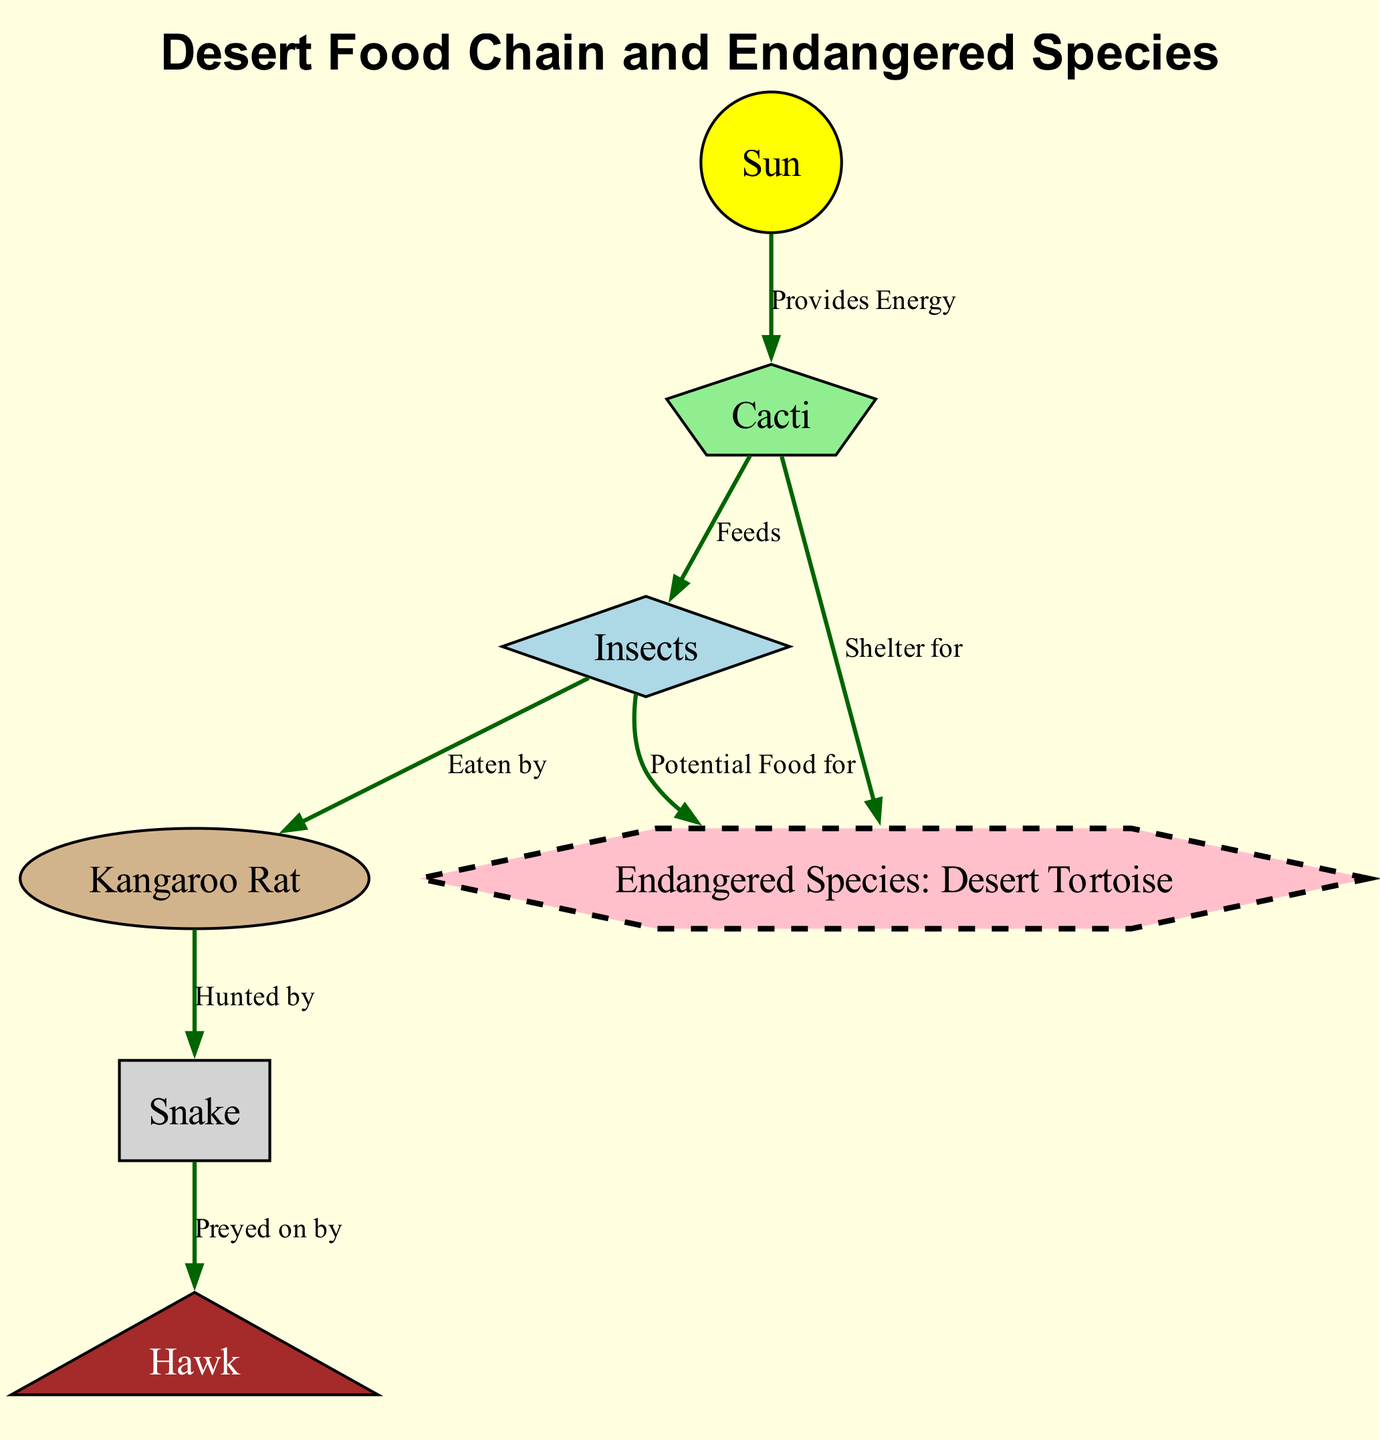What is the title of the diagram? The title is explicitly stated at the top of the diagram, which is designed to provide context for the visual representation of the information contained within.
Answer: Desert Food Chain and Endangered Species How many nodes are present in the diagram? To find the number of nodes, we simply count all unique entities represented in the diagram. The nodes include the Sun, Cacti, Insects, Kangaroo Rat, Snake, Hawk, and Endangered Species. There are a total of seven nodes.
Answer: 7 What relationship does the cacti have with the insects? By examining the edge connecting the two nodes, we see that Cacti feeds Insects, which indicates a direct relationship where one provides sustenance for the other.
Answer: Feeds Which species is classified as endangered in the diagram? The specific node labeled "Endangered Species" is identified as the Desert Tortoise, which signifies it as the endangered species in this food chain context.
Answer: Desert Tortoise How do insects interact with the endangered species? The diagram shows two distinct interactions: insects are a potential food source for the endangered species, while the cacti provide shelter for it, revealing multiple roles for insects in the ecosystem.
Answer: Potential food for and Shelter for Which animal is at the top of the food chain? To determine the top of the food chain, we look for the predator that is preyed on by no other species within the diagram, which in this case is the hawk. Therefore, it stands at the apex of the food chain represented.
Answer: Hawk What does the sun provide in the food chain? The diagram directly states that the Sun provides energy to the cacti, supporting primary productivity and forming the base of the food chain.
Answer: Provides Energy Who hunts the kangaroo rat? By following the directed edge from the kangaroo rat node, we see that the snake is indicated as the predator that hunts the kangaroo rat, showing the predator-prey dynamic within the food chain.
Answer: Snake How many direct connections does the endangered species have? Counting the edges that connect to the endangered species node, we find two connections; one from insects and one from cacti, illustrating its interdependent role in the ecosystem.
Answer: 2 